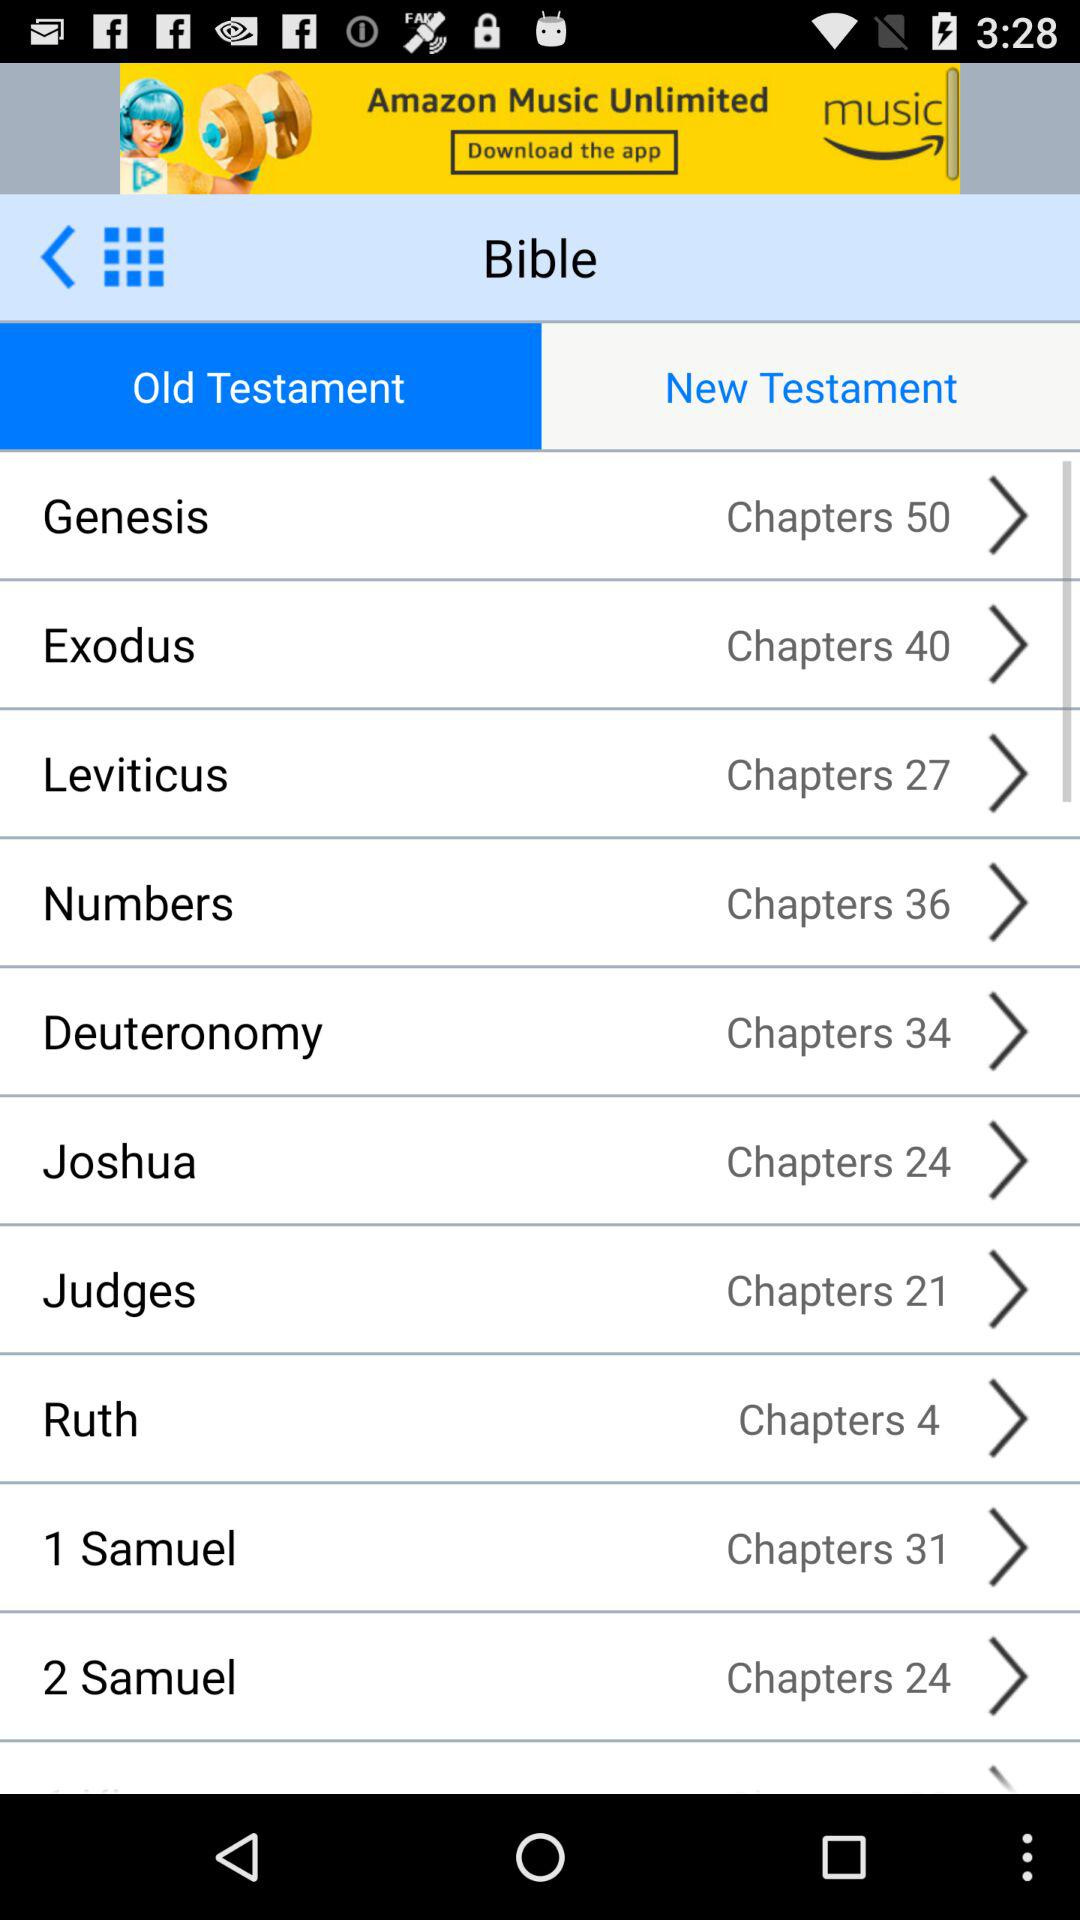How many chapters in total are there in "Genesis"? There are 50 chapters. 